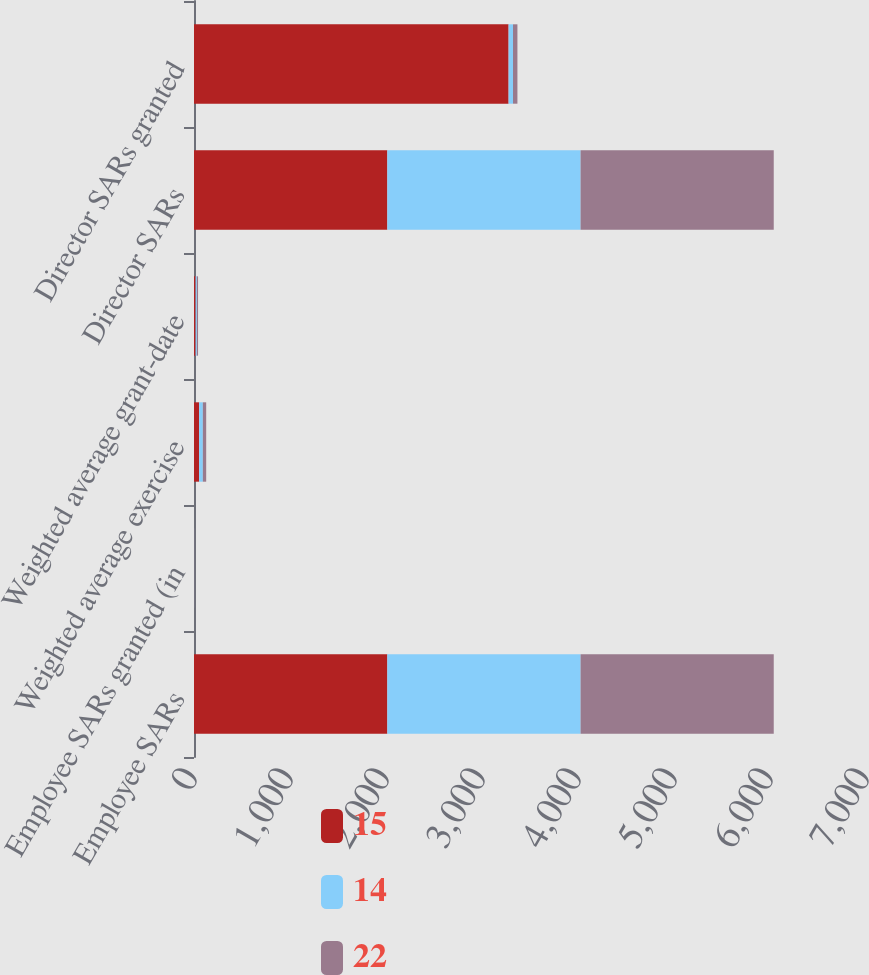<chart> <loc_0><loc_0><loc_500><loc_500><stacked_bar_chart><ecel><fcel>Employee SARs<fcel>Employee SARs granted (in<fcel>Weighted average exercise<fcel>Weighted average grant-date<fcel>Director SARs<fcel>Director SARs granted<nl><fcel>15<fcel>2014<fcel>0.3<fcel>53<fcel>17<fcel>2014<fcel>3277<nl><fcel>14<fcel>2013<fcel>0.7<fcel>39<fcel>13<fcel>2013<fcel>46<nl><fcel>22<fcel>2012<fcel>1<fcel>35<fcel>12<fcel>2012<fcel>46<nl></chart> 